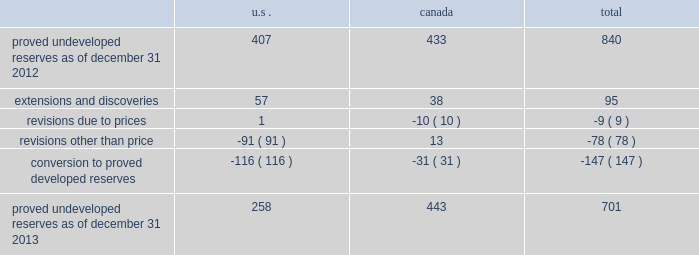Devon energy corporation and subsidiaries notes to consolidated financial statements 2013 ( continued ) proved undeveloped reserves the table presents the changes in devon 2019s total proved undeveloped reserves during 2013 ( in mmboe ) . .
At december 31 , 2013 , devon had 701 mmboe of proved undeveloped reserves .
This represents a 17 percent decrease as compared to 2012 and represents 24 percent of total proved reserves .
Drilling and development activities increased devon 2019s proved undeveloped reserves 95 mmboe and resulted in the conversion of 147 mmboe , or 18 percent , of the 2012 proved undeveloped reserves to proved developed reserves .
Costs incurred related to the development and conversion of devon 2019s proved undeveloped reserves were $ 1.9 billion for 2013 .
Additionally , revisions other than price decreased devon 2019s proved undeveloped reserves 78 mmboe primarily due to evaluations of certain u.s .
Onshore dry-gas areas , which devon does not expect to develop in the next five years .
The largest revisions relate to the dry-gas areas in the cana-woodford shale in western oklahoma , carthage in east texas and the barnett shale in north texas .
A significant amount of devon 2019s proved undeveloped reserves at the end of 2013 related to its jackfish operations .
At december 31 , 2013 and 2012 , devon 2019s jackfish proved undeveloped reserves were 441 mmboe and 429 mmboe , respectively .
Development schedules for the jackfish reserves are primarily controlled by the need to keep the processing plants at their 35000 barrel daily facility capacity .
Processing plant capacity is controlled by factors such as total steam processing capacity , steam-oil ratios and air quality discharge permits .
As a result , these reserves are classified as proved undeveloped for more than five years .
Currently , the development schedule for these reserves extends though the year 2031 .
Price revisions 2013 2013 reserves increased 94 mmboe primarily due to higher gas prices .
Of this increase , 43 mmboe related to the barnett shale and 19 mmboe related to the rocky mountain area .
2012 2013 reserves decreased 171 mmboe primarily due to lower gas prices .
Of this decrease , 100 mmboe related to the barnett shale and 25 mmboe related to the rocky mountain area .
2011 2013 reserves decreased 21 mmboe due to lower gas prices and higher oil prices .
The higher oil prices increased devon 2019s canadian royalty burden , which reduced devon 2019s oil reserves .
Revisions other than price total revisions other than price for 2013 , 2012 and 2011 primarily related to devon 2019s evaluation of certain dry gas regions , with the largest revisions being made in the cana-woodford shale , barnett shale and carthage .
What percentage decrease was there from the 2012 proved undeveloped reserves to 2013 proved undeveloped reserves? 
Computations: (((407 - 258) / 407) * 100)
Answer: 36.60934. 